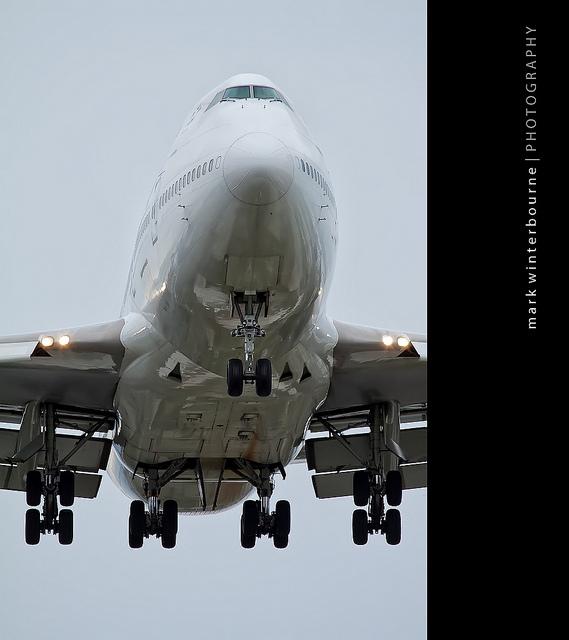How many planes in the sky?
Be succinct. 1. What is the color of the plane?
Short answer required. White. How many wheels are on the plane?
Keep it brief. 12. 